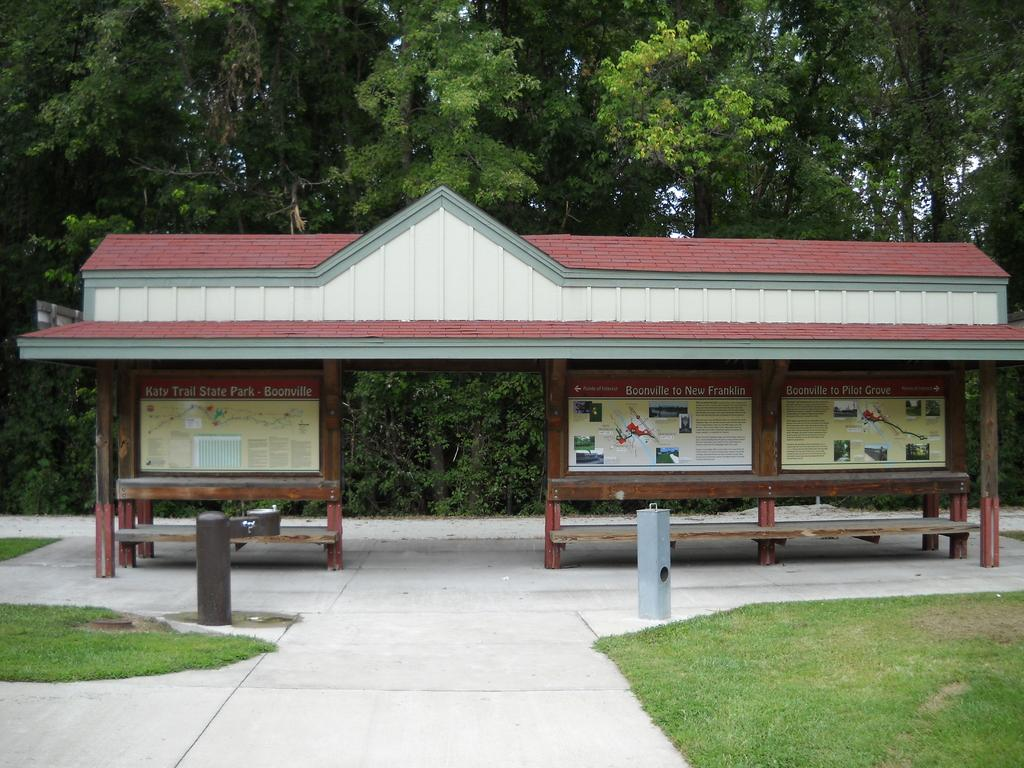What type of vegetation is present in the image? There is grass in the image. What type of seating can be seen in the image? There are benches in the image. What other objects are present in the image? There are boards in the image. What kind of structure is depicted in the image? It appears to be a shelter in the image. What can be seen in the background of the image? There are trees in the background of the image. What type of quiver is hanging on the wall in the image? There is no quiver present in the image. What time is displayed on the clock in the image? There is no clock present in the image. 